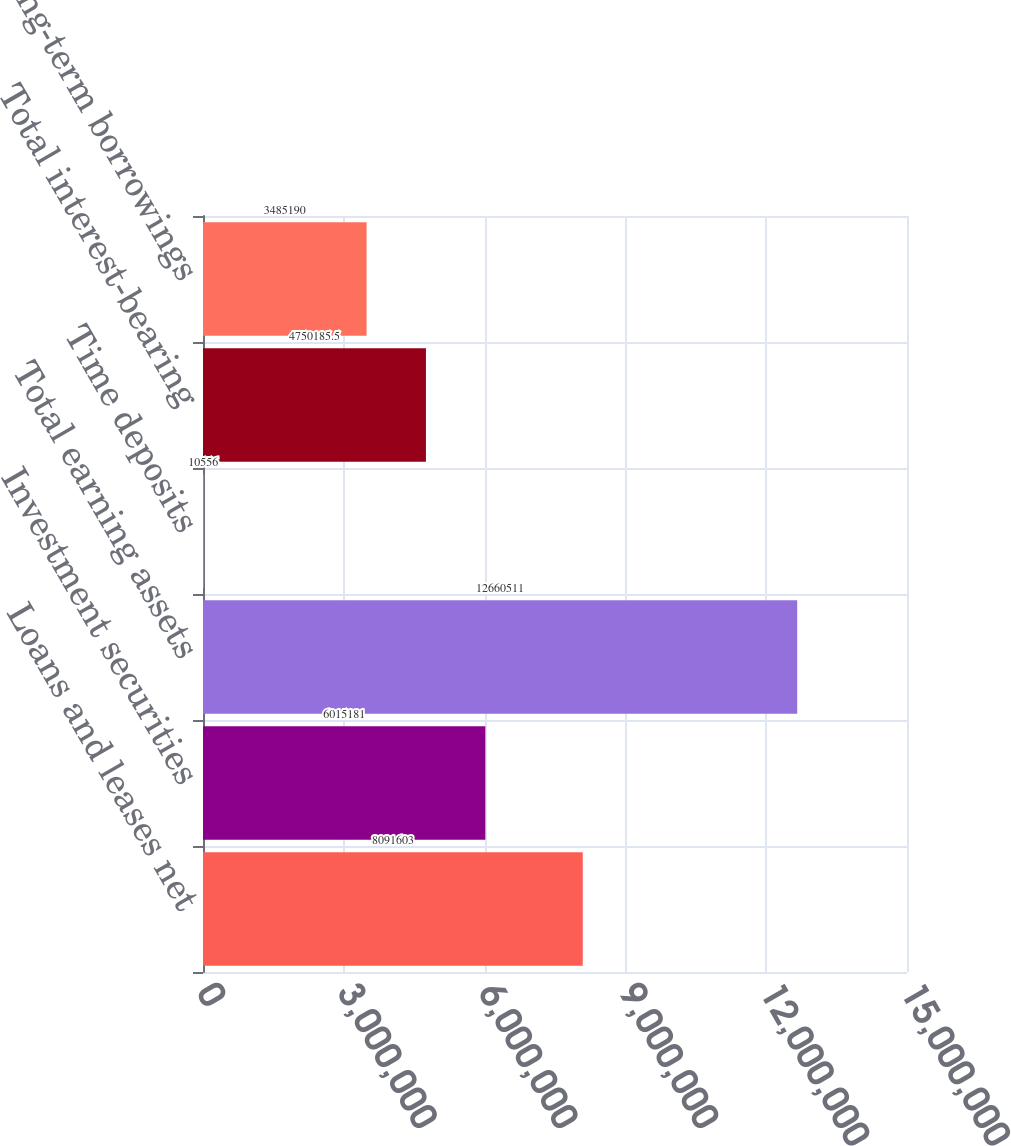Convert chart. <chart><loc_0><loc_0><loc_500><loc_500><bar_chart><fcel>Loans and leases net<fcel>Investment securities<fcel>Total earning assets<fcel>Time deposits<fcel>Total interest-bearing<fcel>Long-term borrowings<nl><fcel>8.0916e+06<fcel>6.01518e+06<fcel>1.26605e+07<fcel>10556<fcel>4.75019e+06<fcel>3.48519e+06<nl></chart> 